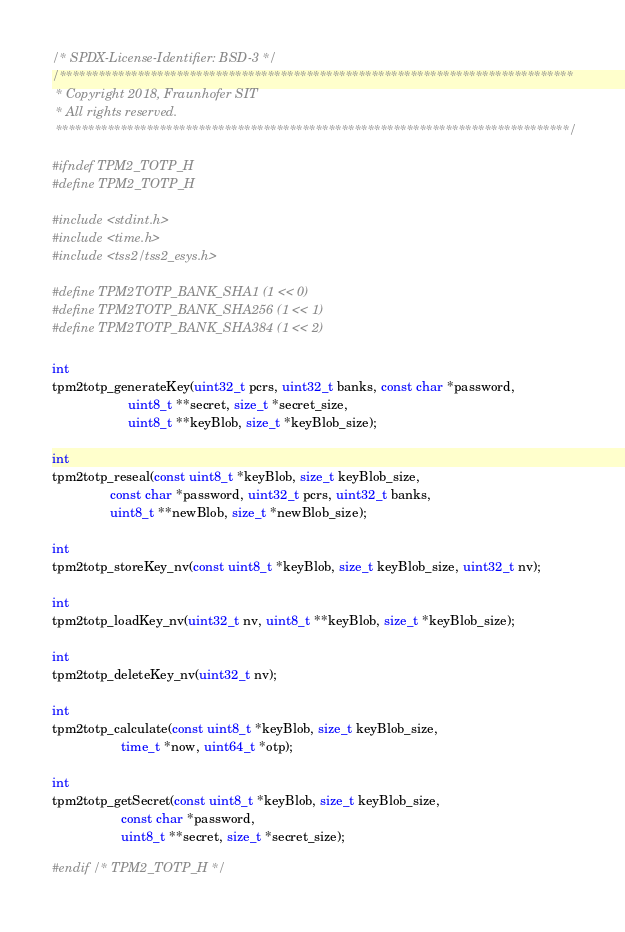Convert code to text. <code><loc_0><loc_0><loc_500><loc_500><_C_>/* SPDX-License-Identifier: BSD-3 */
/*******************************************************************************
 * Copyright 2018, Fraunhofer SIT
 * All rights reserved.
 *******************************************************************************/

#ifndef TPM2_TOTP_H
#define TPM2_TOTP_H

#include <stdint.h>
#include <time.h>
#include <tss2/tss2_esys.h>

#define TPM2TOTP_BANK_SHA1 (1 << 0)
#define TPM2TOTP_BANK_SHA256 (1 << 1)
#define TPM2TOTP_BANK_SHA384 (1 << 2)

int
tpm2totp_generateKey(uint32_t pcrs, uint32_t banks, const char *password,
                     uint8_t **secret, size_t *secret_size,
                     uint8_t **keyBlob, size_t *keyBlob_size);

int
tpm2totp_reseal(const uint8_t *keyBlob, size_t keyBlob_size,
                const char *password, uint32_t pcrs, uint32_t banks,
                uint8_t **newBlob, size_t *newBlob_size);

int
tpm2totp_storeKey_nv(const uint8_t *keyBlob, size_t keyBlob_size, uint32_t nv);

int
tpm2totp_loadKey_nv(uint32_t nv, uint8_t **keyBlob, size_t *keyBlob_size);

int
tpm2totp_deleteKey_nv(uint32_t nv);

int
tpm2totp_calculate(const uint8_t *keyBlob, size_t keyBlob_size,
                   time_t *now, uint64_t *otp);

int
tpm2totp_getSecret(const uint8_t *keyBlob, size_t keyBlob_size, 
                   const char *password,
                   uint8_t **secret, size_t *secret_size);

#endif /* TPM2_TOTP_H */
</code> 